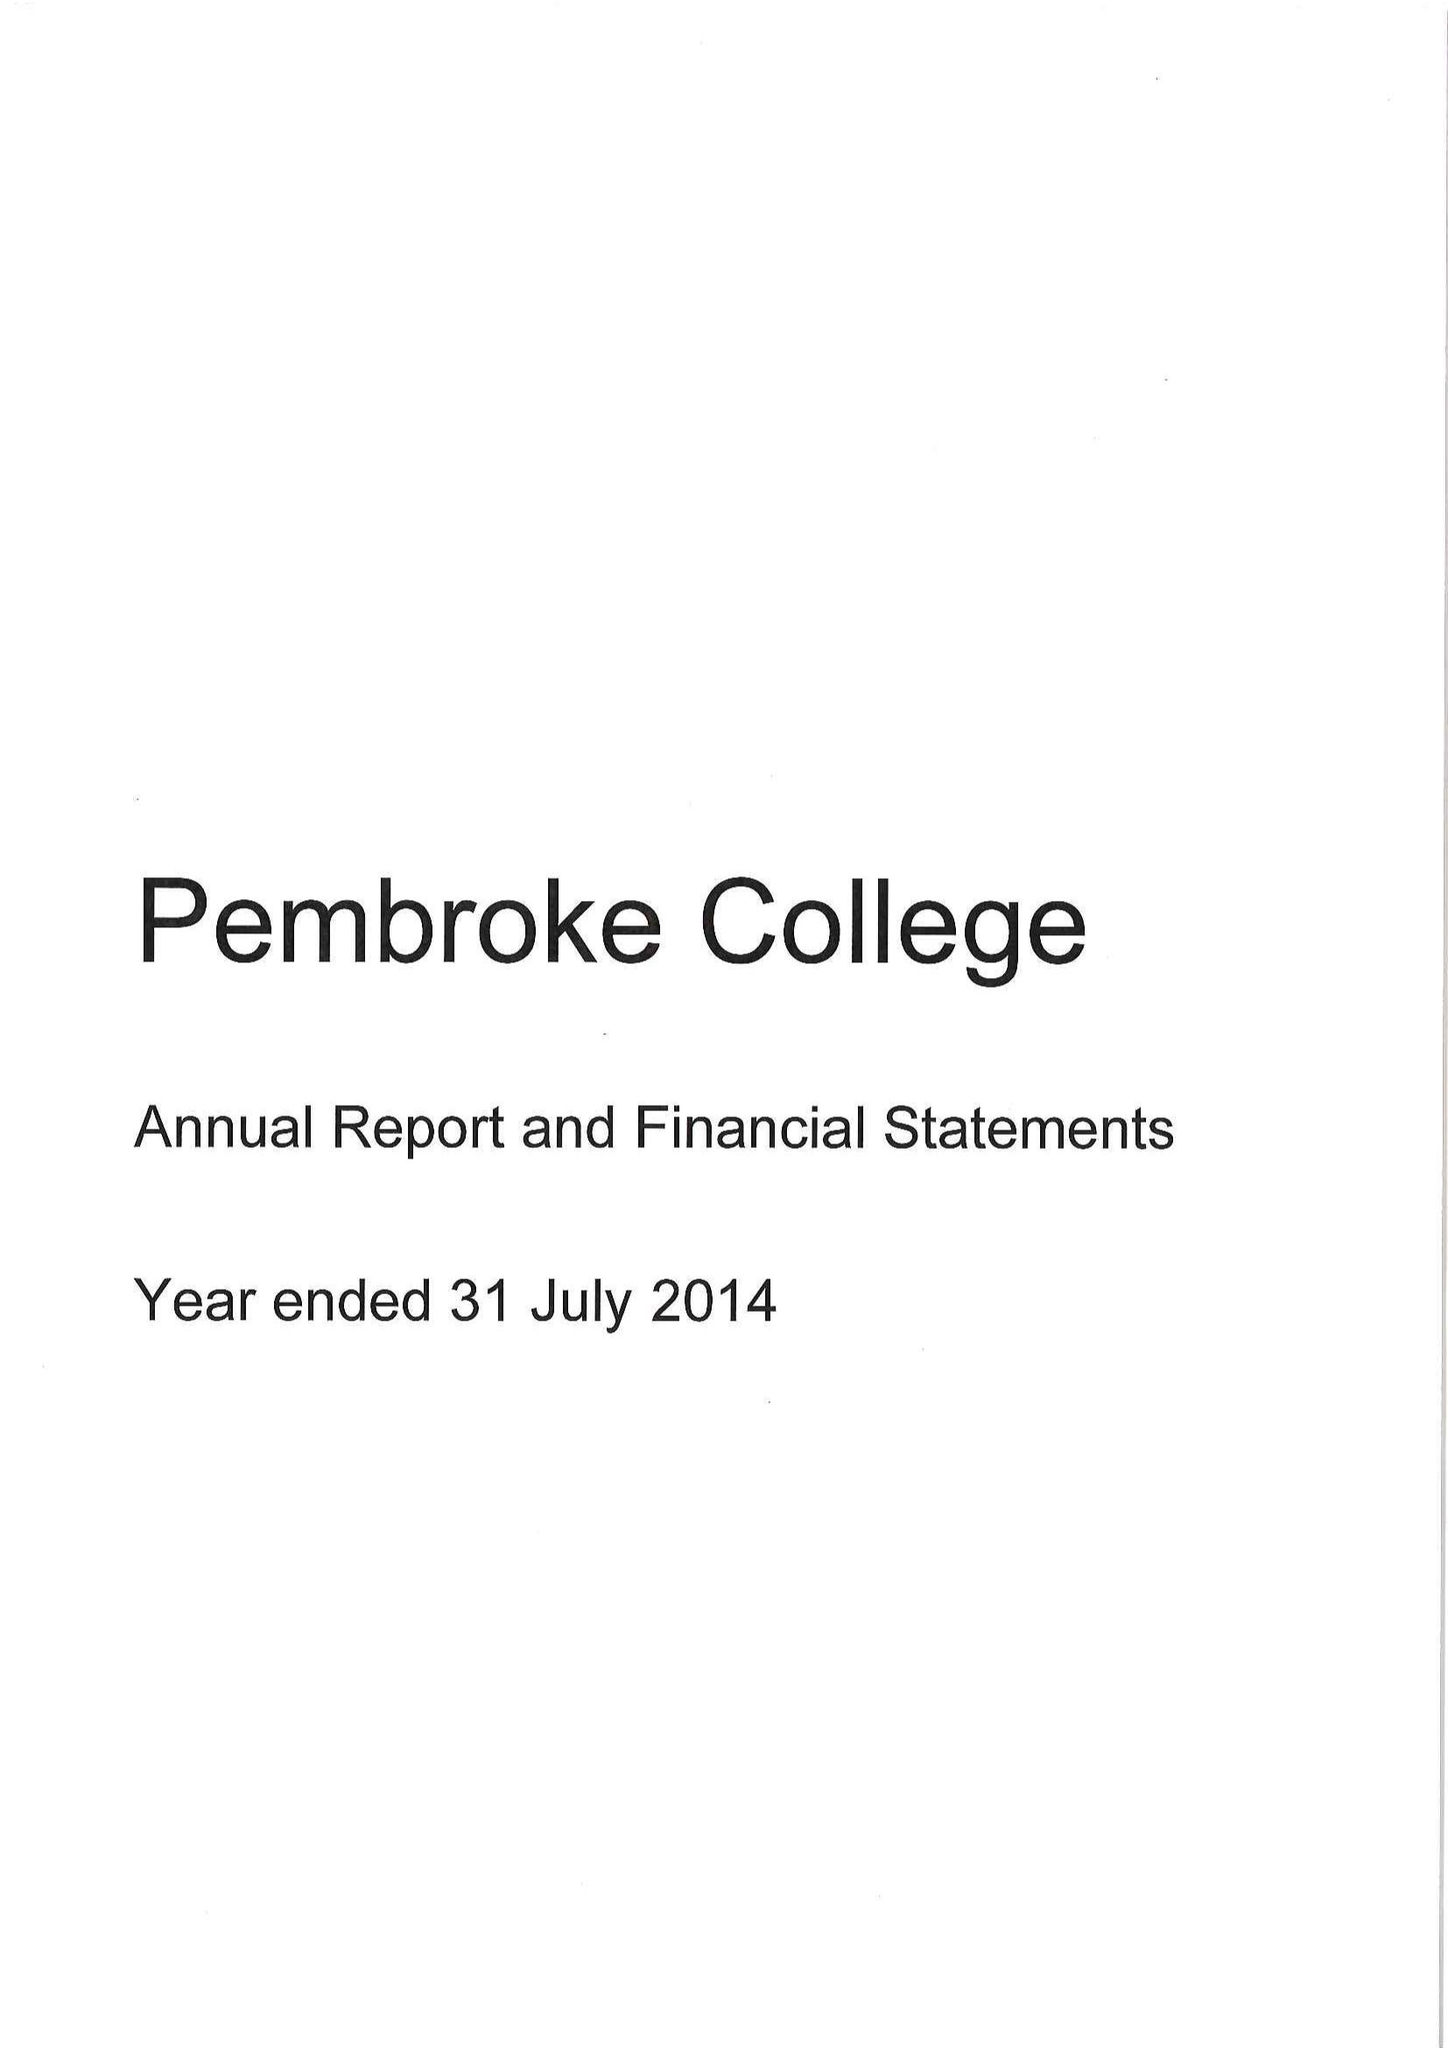What is the value for the report_date?
Answer the question using a single word or phrase. 2014-07-31 